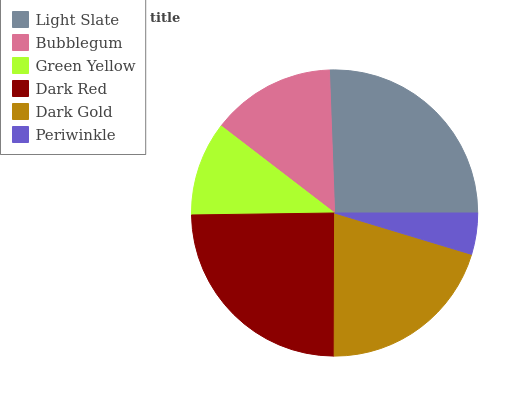Is Periwinkle the minimum?
Answer yes or no. Yes. Is Light Slate the maximum?
Answer yes or no. Yes. Is Bubblegum the minimum?
Answer yes or no. No. Is Bubblegum the maximum?
Answer yes or no. No. Is Light Slate greater than Bubblegum?
Answer yes or no. Yes. Is Bubblegum less than Light Slate?
Answer yes or no. Yes. Is Bubblegum greater than Light Slate?
Answer yes or no. No. Is Light Slate less than Bubblegum?
Answer yes or no. No. Is Dark Gold the high median?
Answer yes or no. Yes. Is Bubblegum the low median?
Answer yes or no. Yes. Is Green Yellow the high median?
Answer yes or no. No. Is Green Yellow the low median?
Answer yes or no. No. 